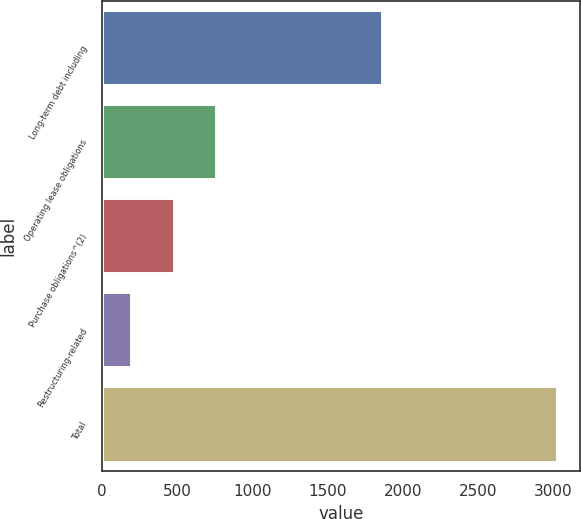<chart> <loc_0><loc_0><loc_500><loc_500><bar_chart><fcel>Long-term debt including<fcel>Operating lease obligations<fcel>Purchase obligations^(2)<fcel>Restructuring-related<fcel>Total<nl><fcel>1861<fcel>761.8<fcel>478.4<fcel>195<fcel>3029<nl></chart> 